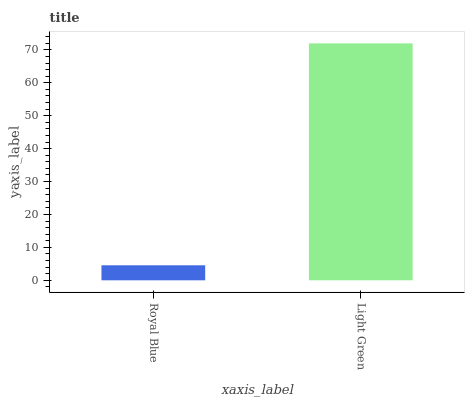Is Light Green the minimum?
Answer yes or no. No. Is Light Green greater than Royal Blue?
Answer yes or no. Yes. Is Royal Blue less than Light Green?
Answer yes or no. Yes. Is Royal Blue greater than Light Green?
Answer yes or no. No. Is Light Green less than Royal Blue?
Answer yes or no. No. Is Light Green the high median?
Answer yes or no. Yes. Is Royal Blue the low median?
Answer yes or no. Yes. Is Royal Blue the high median?
Answer yes or no. No. Is Light Green the low median?
Answer yes or no. No. 